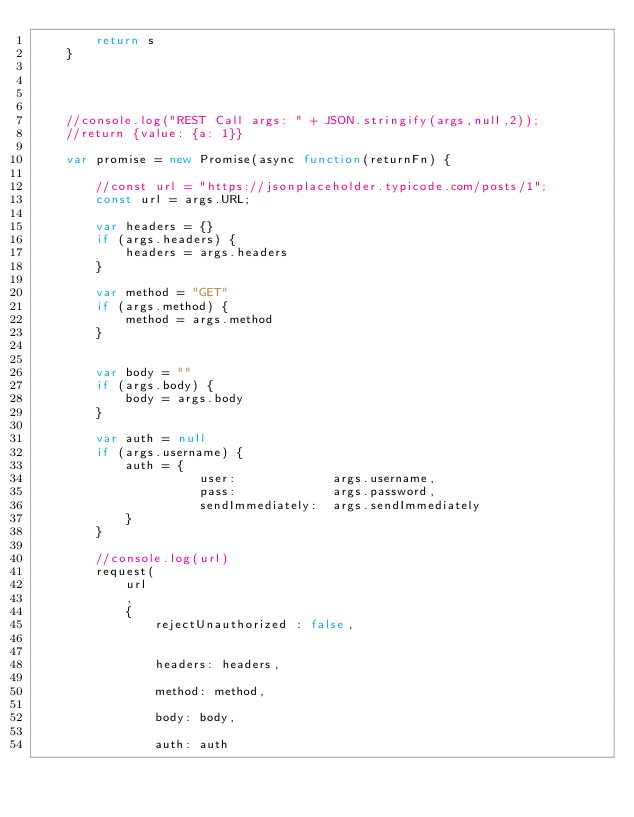Convert code to text. <code><loc_0><loc_0><loc_500><loc_500><_JavaScript_>        return s
    }




    //console.log("REST Call args: " + JSON.stringify(args,null,2));
    //return {value: {a: 1}}

    var promise = new Promise(async function(returnFn) {

        //const url = "https://jsonplaceholder.typicode.com/posts/1";
        const url = args.URL;

        var headers = {}
        if (args.headers) {
            headers = args.headers
        }

        var method = "GET"
        if (args.method) {
            method = args.method
        }


        var body = ""
        if (args.body) {
            body = args.body
        }

        var auth = null
        if (args.username) {
            auth = {
                      user:             args.username,
                      pass:             args.password,
                      sendImmediately:  args.sendImmediately
            }
        }

        //console.log(url)
        request(
            url
            ,
            {
                rejectUnauthorized : false,


                headers: headers,

                method: method,

                body: body,

                auth: auth
</code> 